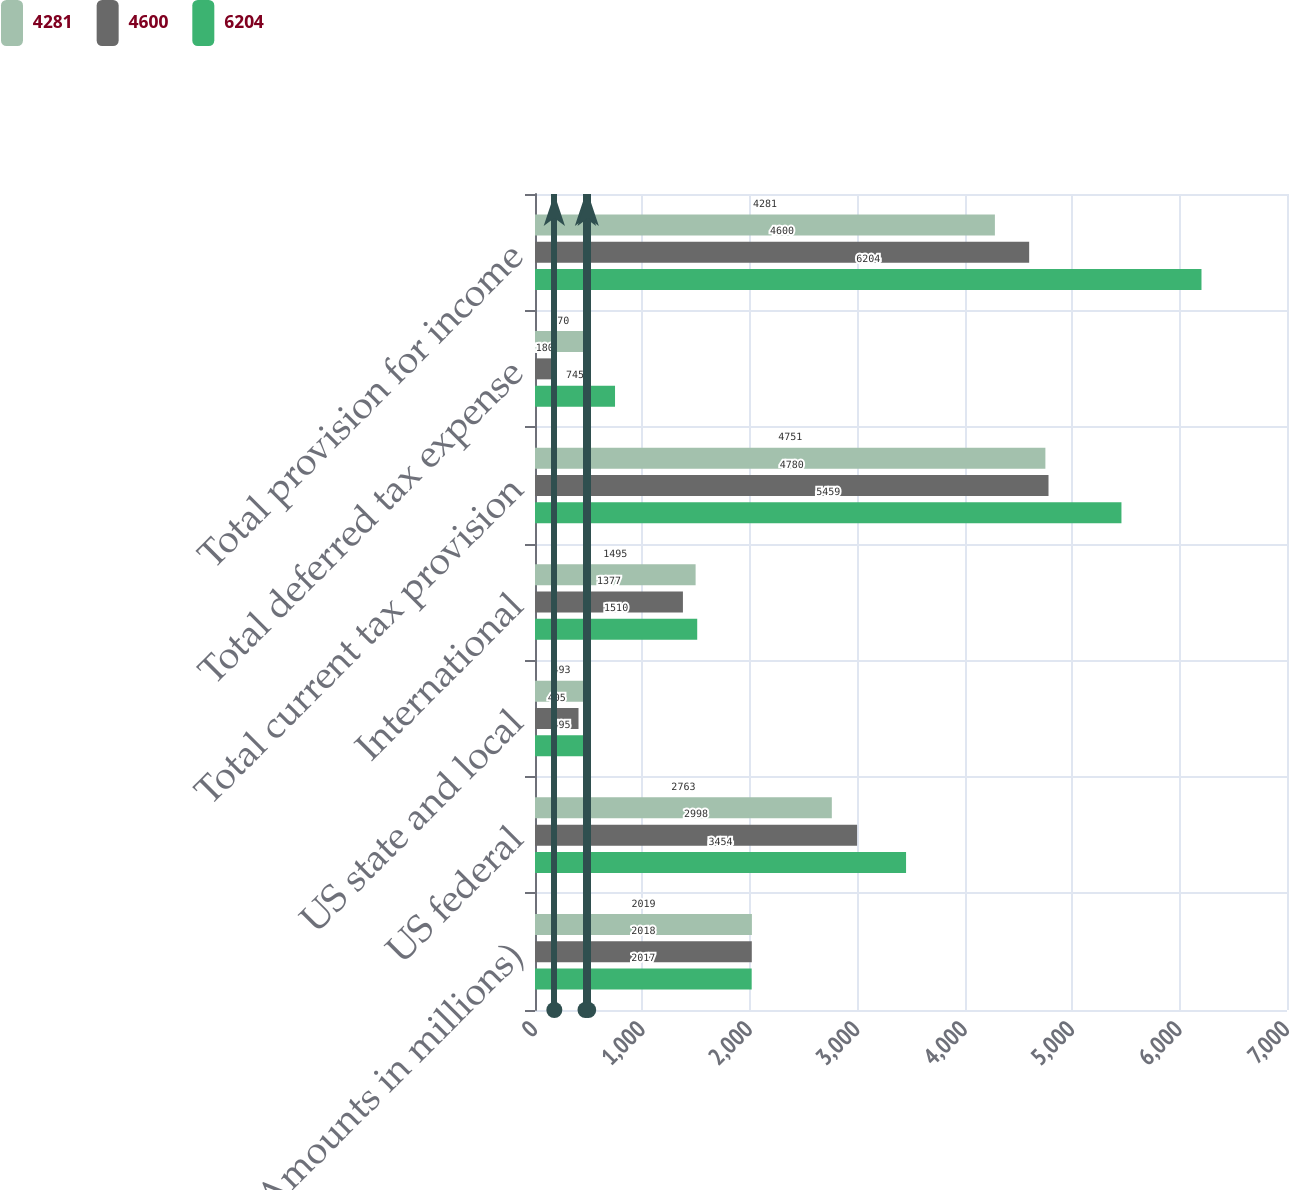Convert chart to OTSL. <chart><loc_0><loc_0><loc_500><loc_500><stacked_bar_chart><ecel><fcel>(Amounts in millions)<fcel>US federal<fcel>US state and local<fcel>International<fcel>Total current tax provision<fcel>Total deferred tax expense<fcel>Total provision for income<nl><fcel>4281<fcel>2019<fcel>2763<fcel>493<fcel>1495<fcel>4751<fcel>470<fcel>4281<nl><fcel>4600<fcel>2018<fcel>2998<fcel>405<fcel>1377<fcel>4780<fcel>180<fcel>4600<nl><fcel>6204<fcel>2017<fcel>3454<fcel>495<fcel>1510<fcel>5459<fcel>745<fcel>6204<nl></chart> 